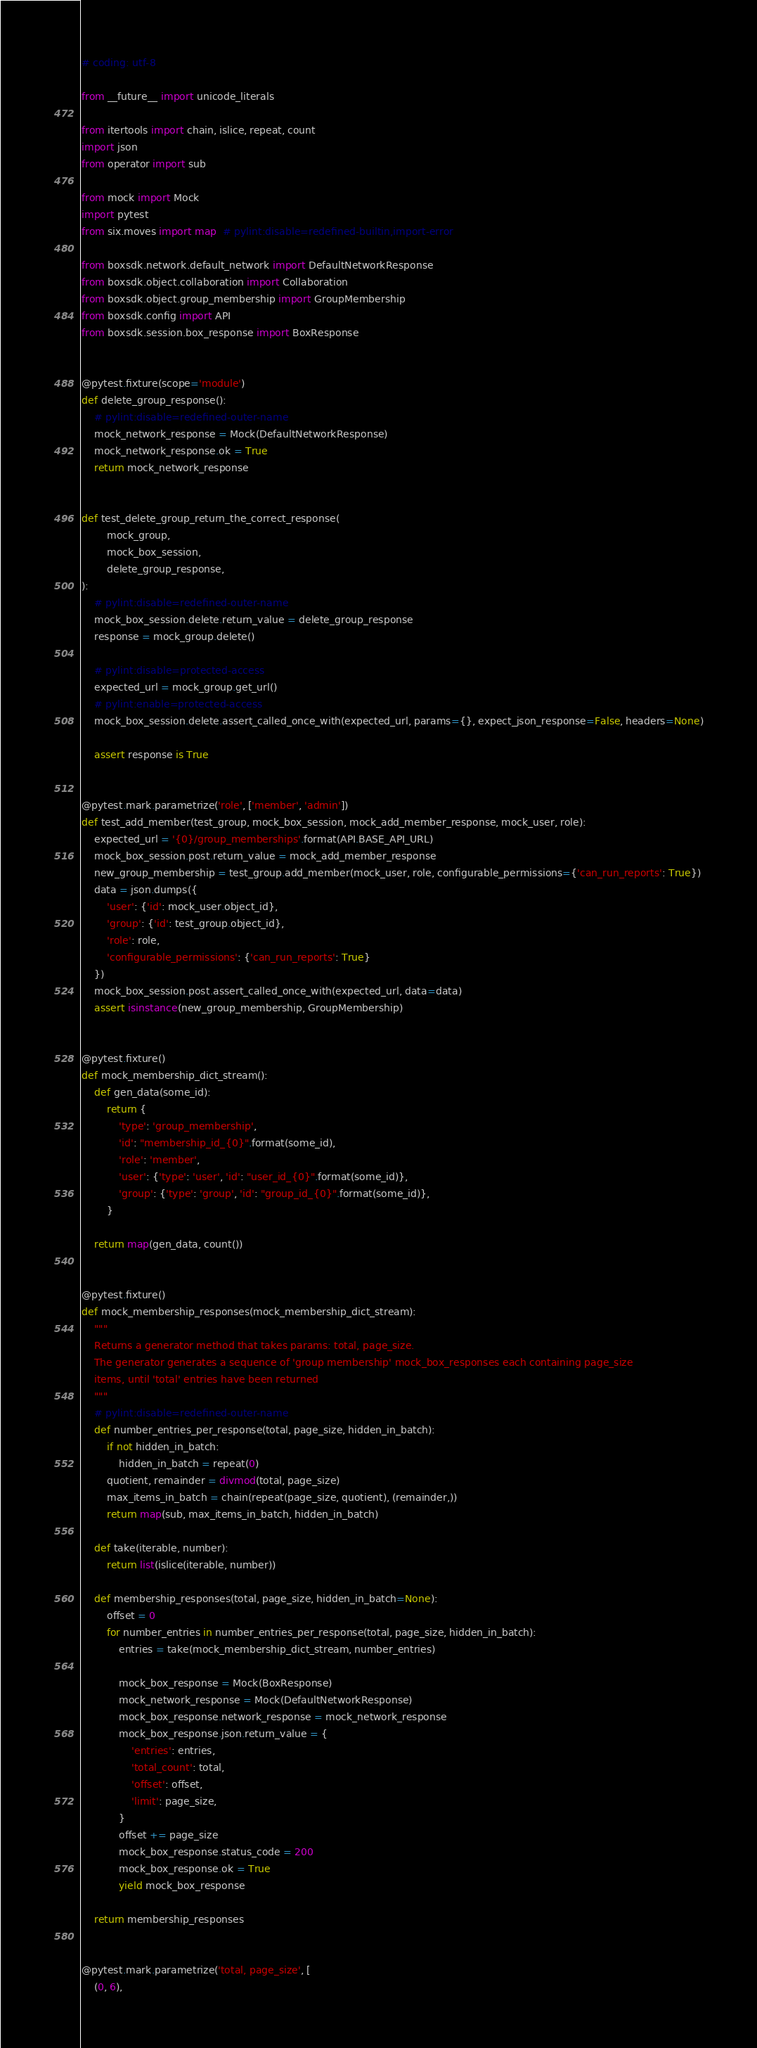<code> <loc_0><loc_0><loc_500><loc_500><_Python_># coding: utf-8

from __future__ import unicode_literals

from itertools import chain, islice, repeat, count
import json
from operator import sub

from mock import Mock
import pytest
from six.moves import map  # pylint:disable=redefined-builtin,import-error

from boxsdk.network.default_network import DefaultNetworkResponse
from boxsdk.object.collaboration import Collaboration
from boxsdk.object.group_membership import GroupMembership
from boxsdk.config import API
from boxsdk.session.box_response import BoxResponse


@pytest.fixture(scope='module')
def delete_group_response():
    # pylint:disable=redefined-outer-name
    mock_network_response = Mock(DefaultNetworkResponse)
    mock_network_response.ok = True
    return mock_network_response


def test_delete_group_return_the_correct_response(
        mock_group,
        mock_box_session,
        delete_group_response,
):
    # pylint:disable=redefined-outer-name
    mock_box_session.delete.return_value = delete_group_response
    response = mock_group.delete()

    # pylint:disable=protected-access
    expected_url = mock_group.get_url()
    # pylint:enable=protected-access
    mock_box_session.delete.assert_called_once_with(expected_url, params={}, expect_json_response=False, headers=None)

    assert response is True


@pytest.mark.parametrize('role', ['member', 'admin'])
def test_add_member(test_group, mock_box_session, mock_add_member_response, mock_user, role):
    expected_url = '{0}/group_memberships'.format(API.BASE_API_URL)
    mock_box_session.post.return_value = mock_add_member_response
    new_group_membership = test_group.add_member(mock_user, role, configurable_permissions={'can_run_reports': True})
    data = json.dumps({
        'user': {'id': mock_user.object_id},
        'group': {'id': test_group.object_id},
        'role': role,
        'configurable_permissions': {'can_run_reports': True}
    })
    mock_box_session.post.assert_called_once_with(expected_url, data=data)
    assert isinstance(new_group_membership, GroupMembership)


@pytest.fixture()
def mock_membership_dict_stream():
    def gen_data(some_id):
        return {
            'type': 'group_membership',
            'id': "membership_id_{0}".format(some_id),
            'role': 'member',
            'user': {'type': 'user', 'id': "user_id_{0}".format(some_id)},
            'group': {'type': 'group', 'id': "group_id_{0}".format(some_id)},
        }

    return map(gen_data, count())


@pytest.fixture()
def mock_membership_responses(mock_membership_dict_stream):
    """
    Returns a generator method that takes params: total, page_size.
    The generator generates a sequence of 'group membership' mock_box_responses each containing page_size
    items, until 'total' entries have been returned
    """
    # pylint:disable=redefined-outer-name
    def number_entries_per_response(total, page_size, hidden_in_batch):
        if not hidden_in_batch:
            hidden_in_batch = repeat(0)
        quotient, remainder = divmod(total, page_size)
        max_items_in_batch = chain(repeat(page_size, quotient), (remainder,))
        return map(sub, max_items_in_batch, hidden_in_batch)

    def take(iterable, number):
        return list(islice(iterable, number))

    def membership_responses(total, page_size, hidden_in_batch=None):
        offset = 0
        for number_entries in number_entries_per_response(total, page_size, hidden_in_batch):
            entries = take(mock_membership_dict_stream, number_entries)

            mock_box_response = Mock(BoxResponse)
            mock_network_response = Mock(DefaultNetworkResponse)
            mock_box_response.network_response = mock_network_response
            mock_box_response.json.return_value = {
                'entries': entries,
                'total_count': total,
                'offset': offset,
                'limit': page_size,
            }
            offset += page_size
            mock_box_response.status_code = 200
            mock_box_response.ok = True
            yield mock_box_response

    return membership_responses


@pytest.mark.parametrize('total, page_size', [
    (0, 6),</code> 